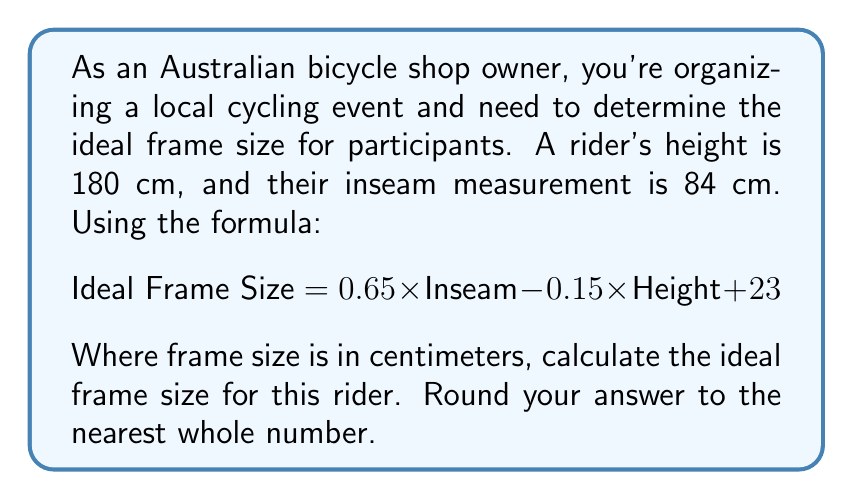Give your solution to this math problem. To solve this problem, we'll follow these steps:

1. Identify the given values:
   - Rider's height = 180 cm
   - Rider's inseam = 84 cm

2. Substitute these values into the formula:
   $$ \text{Ideal Frame Size} = 0.65 \times 84 - 0.15 \times 180 + 23 $$

3. Solve the equation:
   $$ \begin{align}
   \text{Ideal Frame Size} &= 0.65 \times 84 - 0.15 \times 180 + 23 \\
   &= 54.6 - 27 + 23 \\
   &= 50.6 \text{ cm}
   \end{align} $$

4. Round the result to the nearest whole number:
   50.6 cm rounds to 51 cm

Therefore, the ideal frame size for this rider is 51 cm.
Answer: 51 cm 